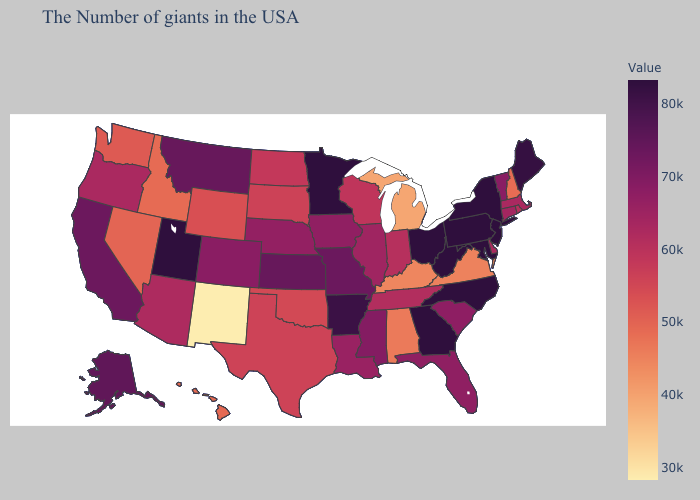Which states have the lowest value in the South?
Answer briefly. Kentucky. Does Tennessee have the highest value in the South?
Quick response, please. No. Among the states that border North Carolina , which have the lowest value?
Give a very brief answer. Virginia. Which states have the highest value in the USA?
Short answer required. New York, New Jersey, Maryland, Pennsylvania, North Carolina, West Virginia, Ohio, Georgia, Minnesota, Utah. Which states have the lowest value in the USA?
Concise answer only. New Mexico. Among the states that border North Carolina , which have the lowest value?
Short answer required. Virginia. 